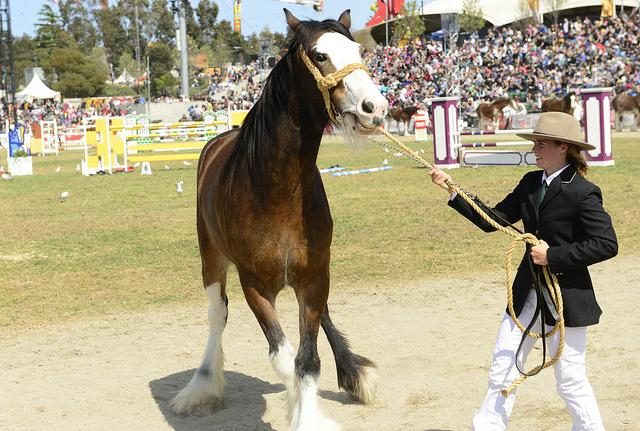What is it called when this animal moves?

Choices:
A) trot
B) slither
C) slime
D) roll trot 